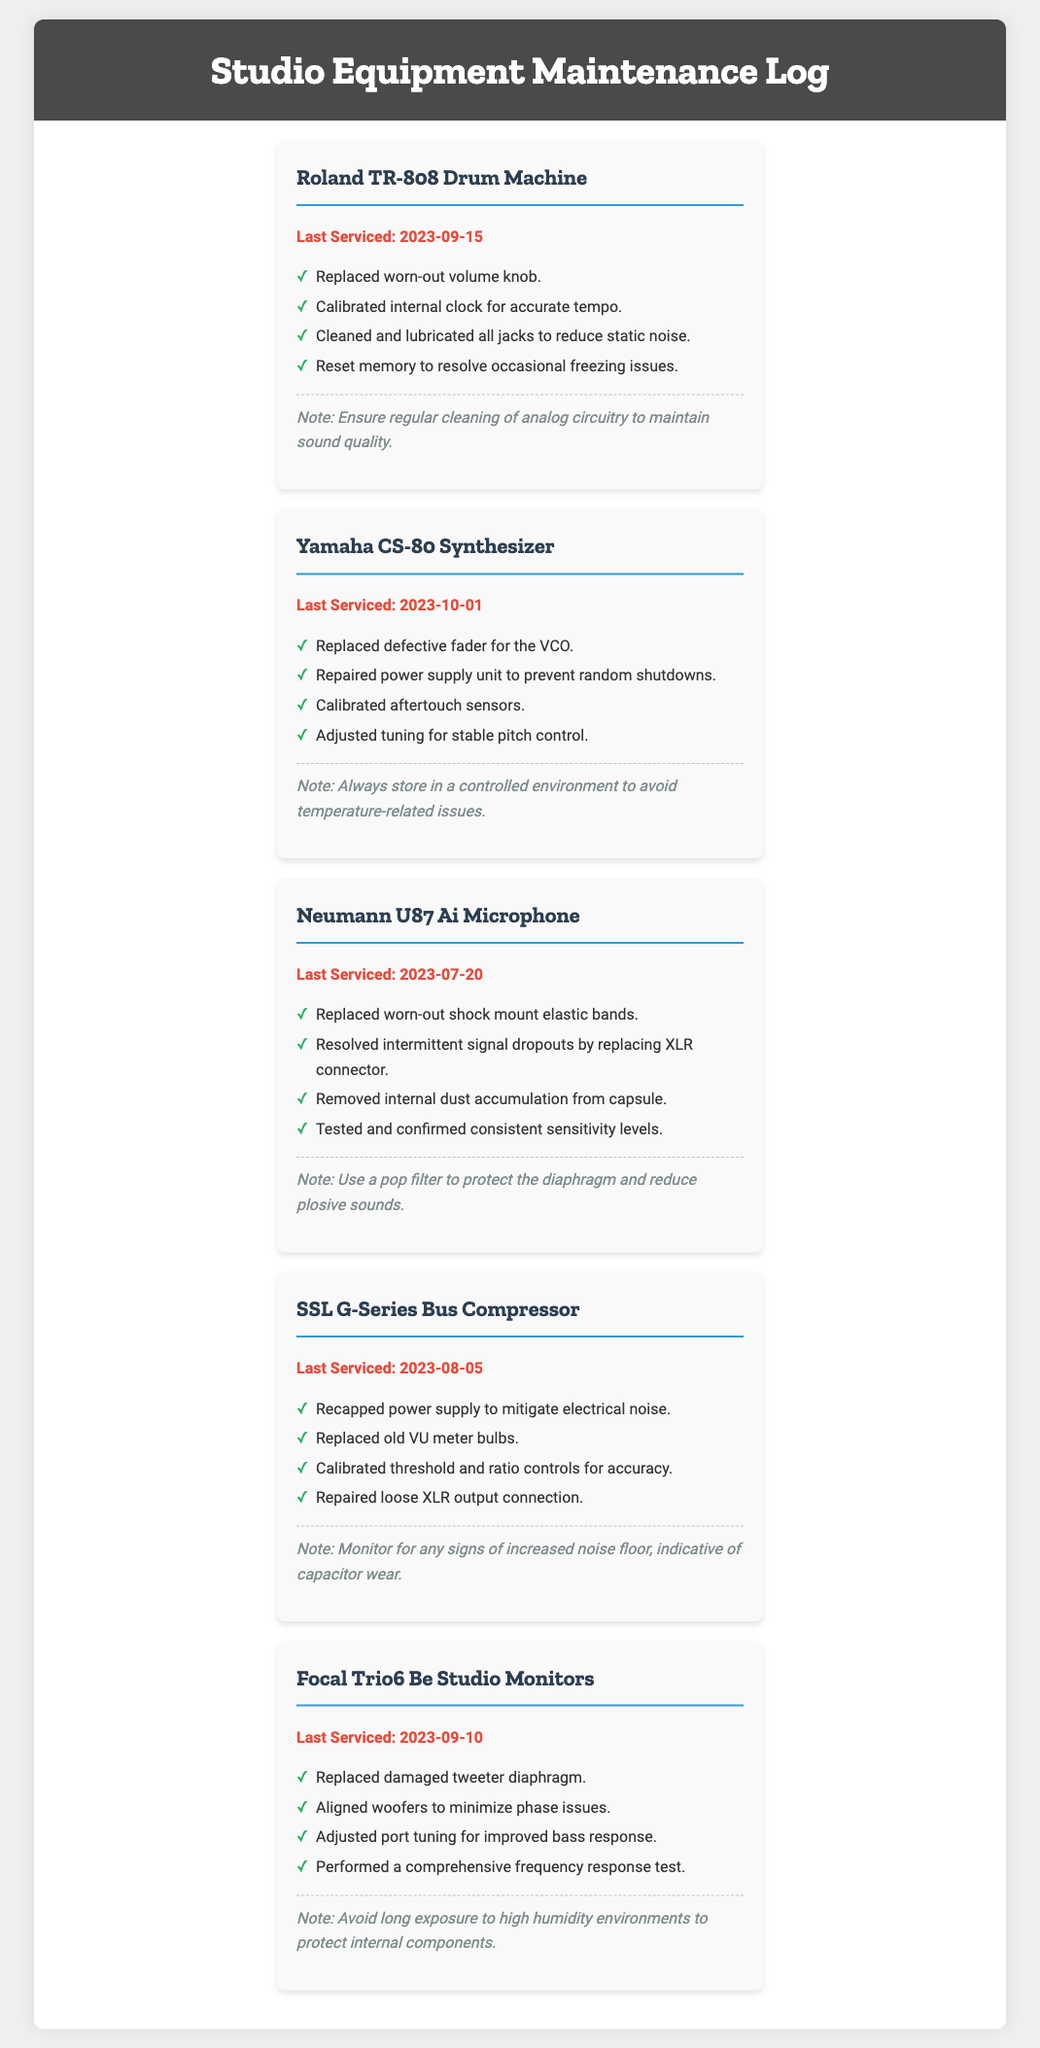What is the last service date for the Roland TR-808? The last service date for the Roland TR-808 is mentioned in the document.
Answer: 2023-09-15 What issue was resolved for the Yamaha CS-80 Synthesizer? The document lists multiple resolved issues for the Yamaha CS-80 Synthesizer.
Answer: Replaced defective fader for the VCO Which microphone had its last servicing on 2023-07-20? The document provides the last service dates for different pieces of equipment, indicating which was last serviced on that date.
Answer: Neumann U87 Ai Microphone How many issues were resolved for the Focal Trio6 Be Studio Monitors? The document provides a list of resolved issues for the Focal Trio6 Be Studio Monitors, which indicates the number of issues addressed.
Answer: 4 What maintenance note is associated with the SSL G-Series Bus Compressor? The document contains maintenance notes specific to each piece of equipment, outlining what to monitor or consider.
Answer: Monitor for any signs of increased noise floor, indicative of capacitor wear What was the last servicing date for the Neumann U87 Ai Microphone? The last service date for the Neumann U87 Ai Microphone is directly mentioned in the log.
Answer: 2023-07-20 What specific part was replaced on the Focal Trio6 Be Studio Monitors? The document mentions specific parts that were replaced in the maintenance notes for the Focal Trio6.
Answer: Replaced damaged tweeter diaphragm What does the maintenance note for the Yamaha CS-80 suggest? The maintenance note for the Yamaha CS-80 outlines storage conditions to avoid issues, which is found in the document.
Answer: Always store in a controlled environment to avoid temperature-related issues Which piece of equipment had its power supply unit repaired? The document lists various maintenance tasks for each piece of equipment indicating what repairs were made.
Answer: Yamaha CS-80 Synthesizer 